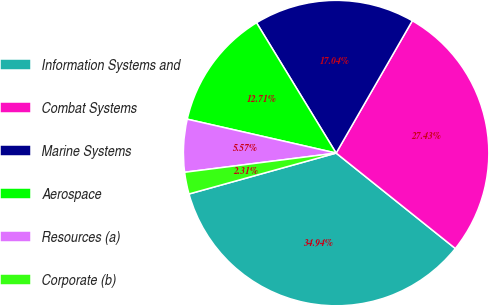Convert chart. <chart><loc_0><loc_0><loc_500><loc_500><pie_chart><fcel>Information Systems and<fcel>Combat Systems<fcel>Marine Systems<fcel>Aerospace<fcel>Resources (a)<fcel>Corporate (b)<nl><fcel>34.94%<fcel>27.43%<fcel>17.04%<fcel>12.71%<fcel>5.57%<fcel>2.31%<nl></chart> 